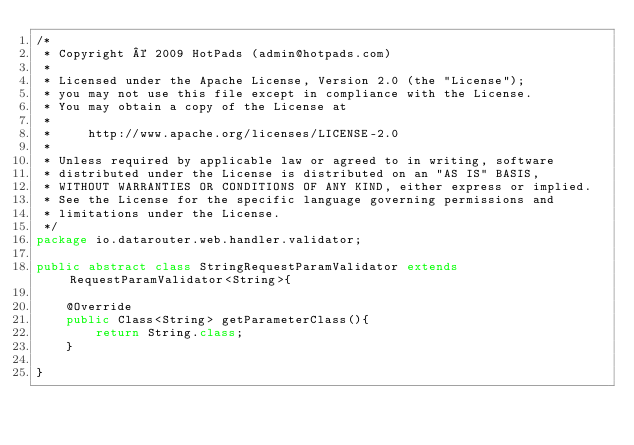<code> <loc_0><loc_0><loc_500><loc_500><_Java_>/*
 * Copyright © 2009 HotPads (admin@hotpads.com)
 *
 * Licensed under the Apache License, Version 2.0 (the "License");
 * you may not use this file except in compliance with the License.
 * You may obtain a copy of the License at
 *
 *     http://www.apache.org/licenses/LICENSE-2.0
 *
 * Unless required by applicable law or agreed to in writing, software
 * distributed under the License is distributed on an "AS IS" BASIS,
 * WITHOUT WARRANTIES OR CONDITIONS OF ANY KIND, either express or implied.
 * See the License for the specific language governing permissions and
 * limitations under the License.
 */
package io.datarouter.web.handler.validator;

public abstract class StringRequestParamValidator extends RequestParamValidator<String>{

	@Override
	public Class<String> getParameterClass(){
		return String.class;
	}

}
</code> 